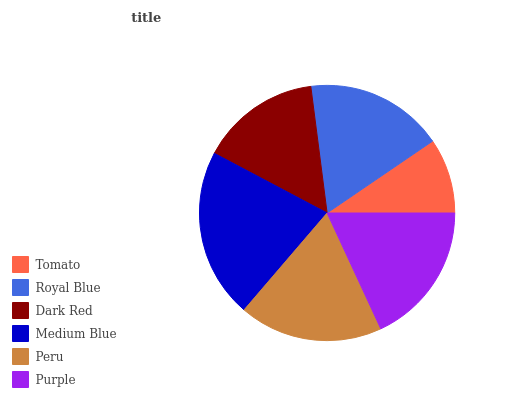Is Tomato the minimum?
Answer yes or no. Yes. Is Medium Blue the maximum?
Answer yes or no. Yes. Is Royal Blue the minimum?
Answer yes or no. No. Is Royal Blue the maximum?
Answer yes or no. No. Is Royal Blue greater than Tomato?
Answer yes or no. Yes. Is Tomato less than Royal Blue?
Answer yes or no. Yes. Is Tomato greater than Royal Blue?
Answer yes or no. No. Is Royal Blue less than Tomato?
Answer yes or no. No. Is Purple the high median?
Answer yes or no. Yes. Is Royal Blue the low median?
Answer yes or no. Yes. Is Dark Red the high median?
Answer yes or no. No. Is Purple the low median?
Answer yes or no. No. 